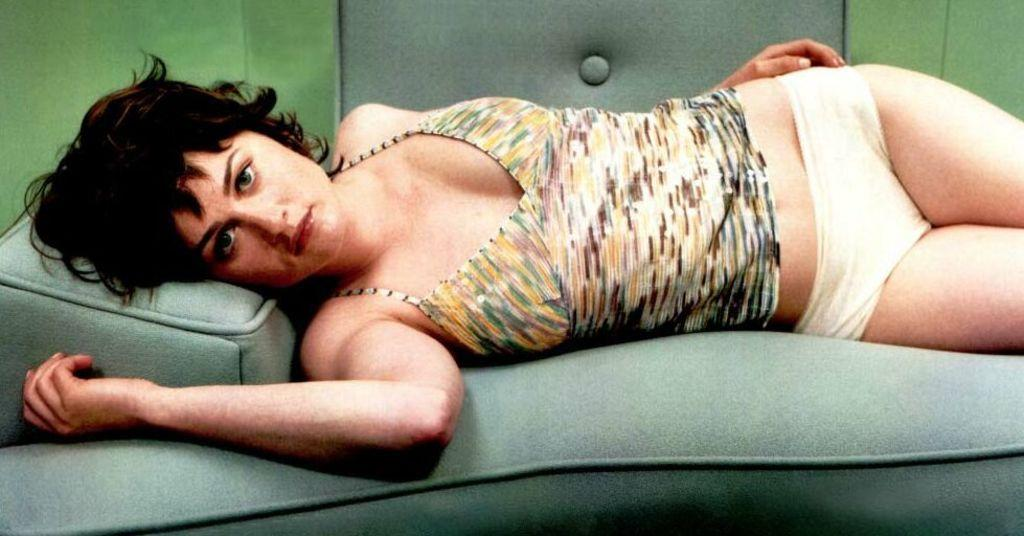Who is the main subject in the image? There is a woman in the image. What is the woman doing in the image? The woman is lying on a sofa. What type of sweater is the woman wearing in the image? The provided facts do not mention any clothing, including a sweater, so we cannot determine what type of sweater the woman is wearing in the image. 